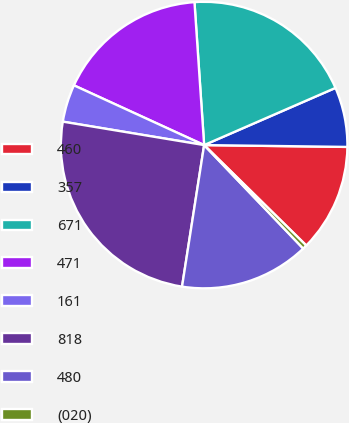Convert chart. <chart><loc_0><loc_0><loc_500><loc_500><pie_chart><fcel>460<fcel>357<fcel>671<fcel>471<fcel>161<fcel>818<fcel>480<fcel>(020)<nl><fcel>12.16%<fcel>6.74%<fcel>19.54%<fcel>17.08%<fcel>4.23%<fcel>25.15%<fcel>14.62%<fcel>0.48%<nl></chart> 